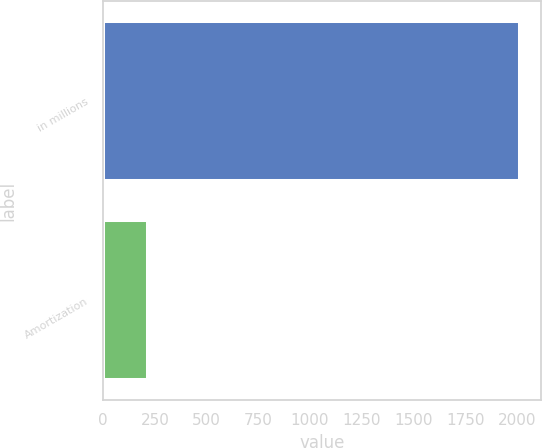Convert chart. <chart><loc_0><loc_0><loc_500><loc_500><bar_chart><fcel>in millions<fcel>Amortization<nl><fcel>2014<fcel>217<nl></chart> 